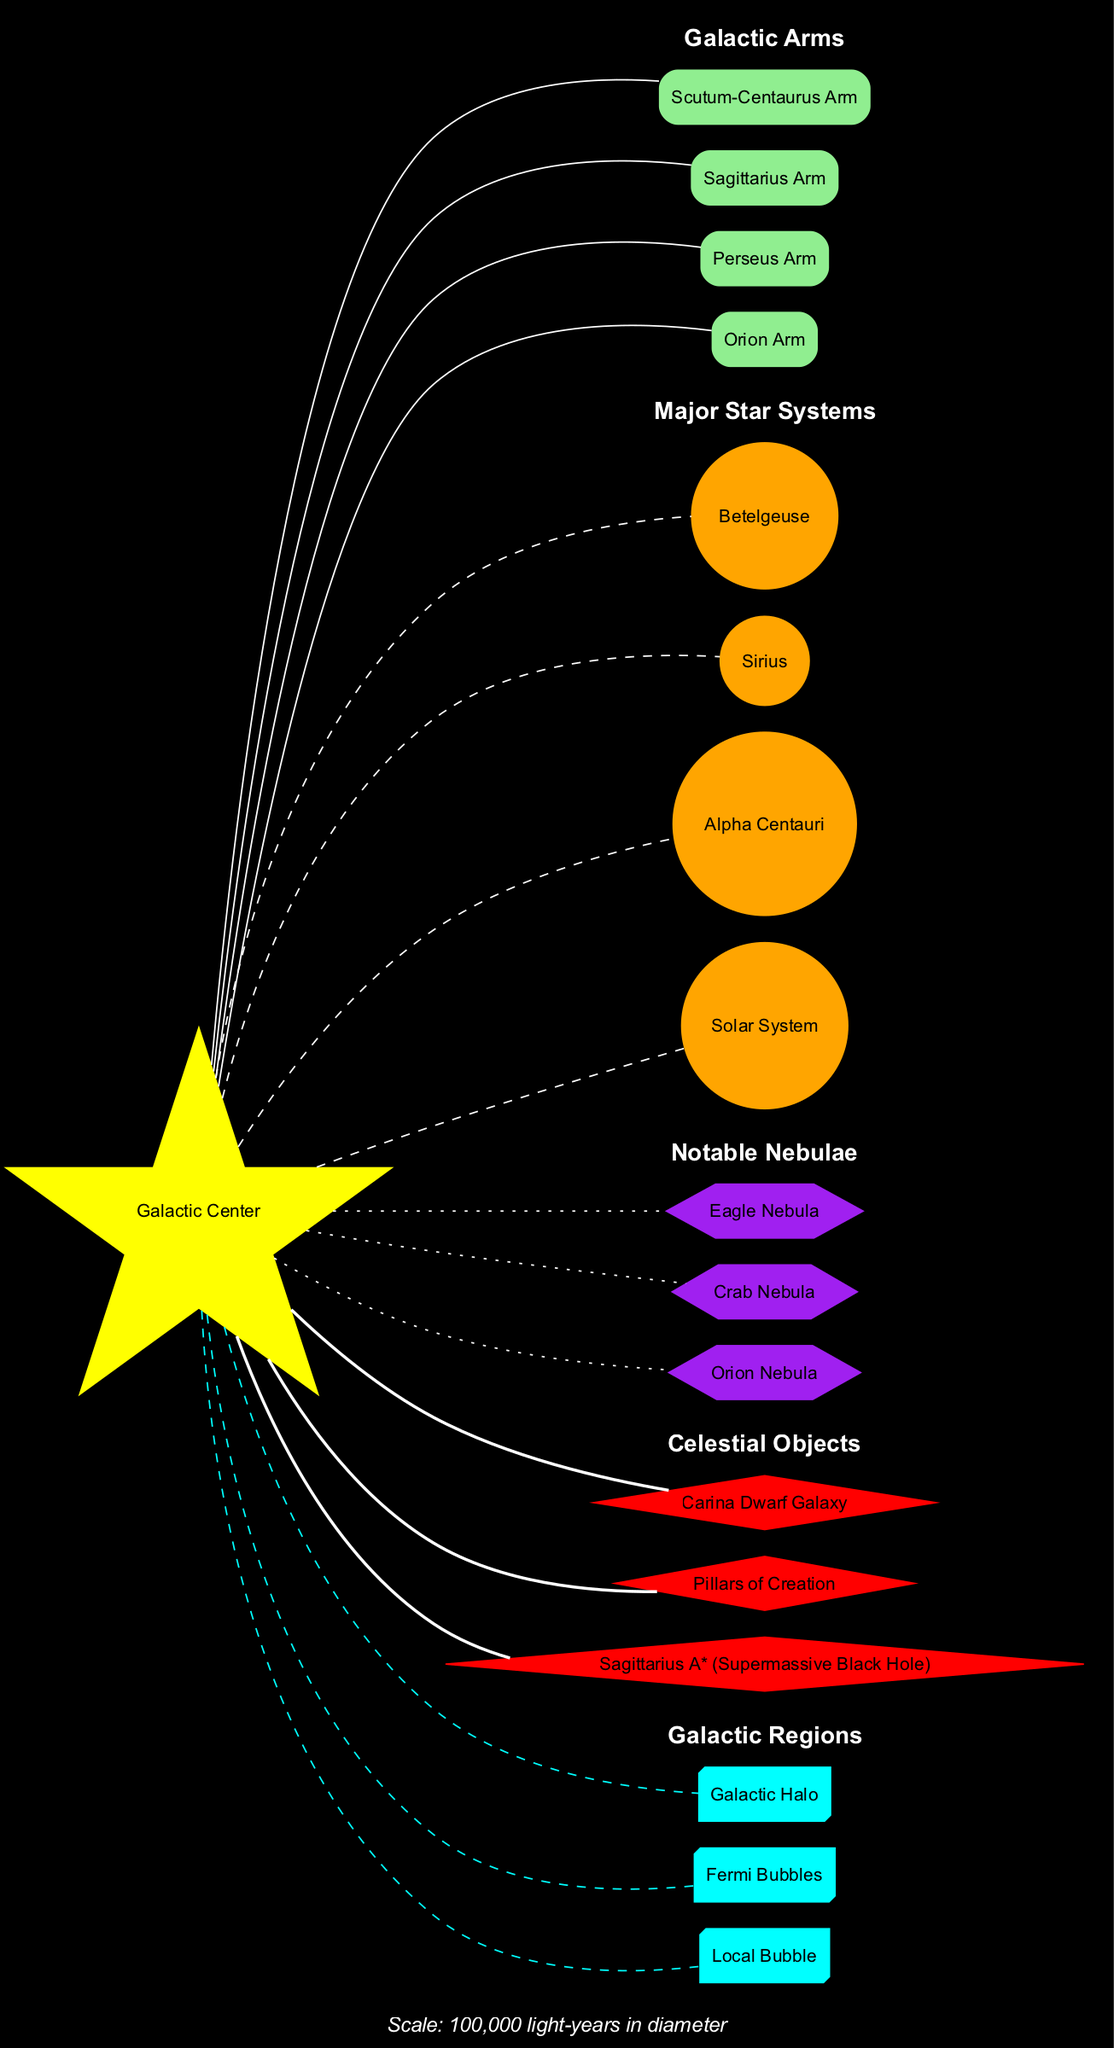What is located at the center of the Milky Way galaxy? The diagram indicates that the "Galactic Center" is at the center, which is labeled clearly.
Answer: Galactic Center How many major star systems are depicted in the diagram? The diagram lists four major star systems: Solar System, Alpha Centauri, Sirius, and Betelgeuse. Therefore, the total count is four.
Answer: 4 Which arm of the Milky Way is known as the Orion Arm? The diagram shows the Orion Arm as one of the galactic arms branching out from the Galactic Center, specifically labeled in its section.
Answer: Orion Arm What color represents the nebulae in the diagram? According to the diagram's legend and color scheme, nebulae are represented in purple. The nebulae shapes confirmed this.
Answer: Purple List one celestial object that is connected to the Galactic Center. The diagram shows that Sagittarius A*, the supermassive black hole, is connected to the Galactic Center with a bold edge, denoting its significance.
Answer: Sagittarius A* (Supermassive Black Hole) How are the regions of the galaxy depicted in terms of shape? The regions are represented in a three-dimensional box shape, as evident in the diagram's depiction and labeled cluster for regions.
Answer: Box3D Which type of nebula is represented by the Orion Nebula? In the diagram's section for notable nebulae, the Orion Nebula is shown as a six-sided polygon, indicating it is a nebula, supported by the label.
Answer: Nebula Which star system is closest to our Solar System? The diagram includes Alpha Centauri as one of the major star systems; given its proximity to our Solar System, it is identified as the closest.
Answer: Alpha Centauri What is the scale of the entire Milky Way galaxy in the diagram? The scale is explicitly labeled in the diagram as "100,000 light-years in diameter," providing a direct measure of the galaxy's size.
Answer: 100,000 light-years in diameter 